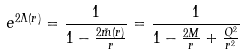Convert formula to latex. <formula><loc_0><loc_0><loc_500><loc_500>e ^ { 2 \Lambda ( r ) } = \frac { 1 } { 1 - \frac { 2 \tilde { m } ( r ) } { r } } = \frac { 1 } { 1 - \frac { 2 M } { r } + \frac { Q ^ { 2 } } { r ^ { 2 } } }</formula> 